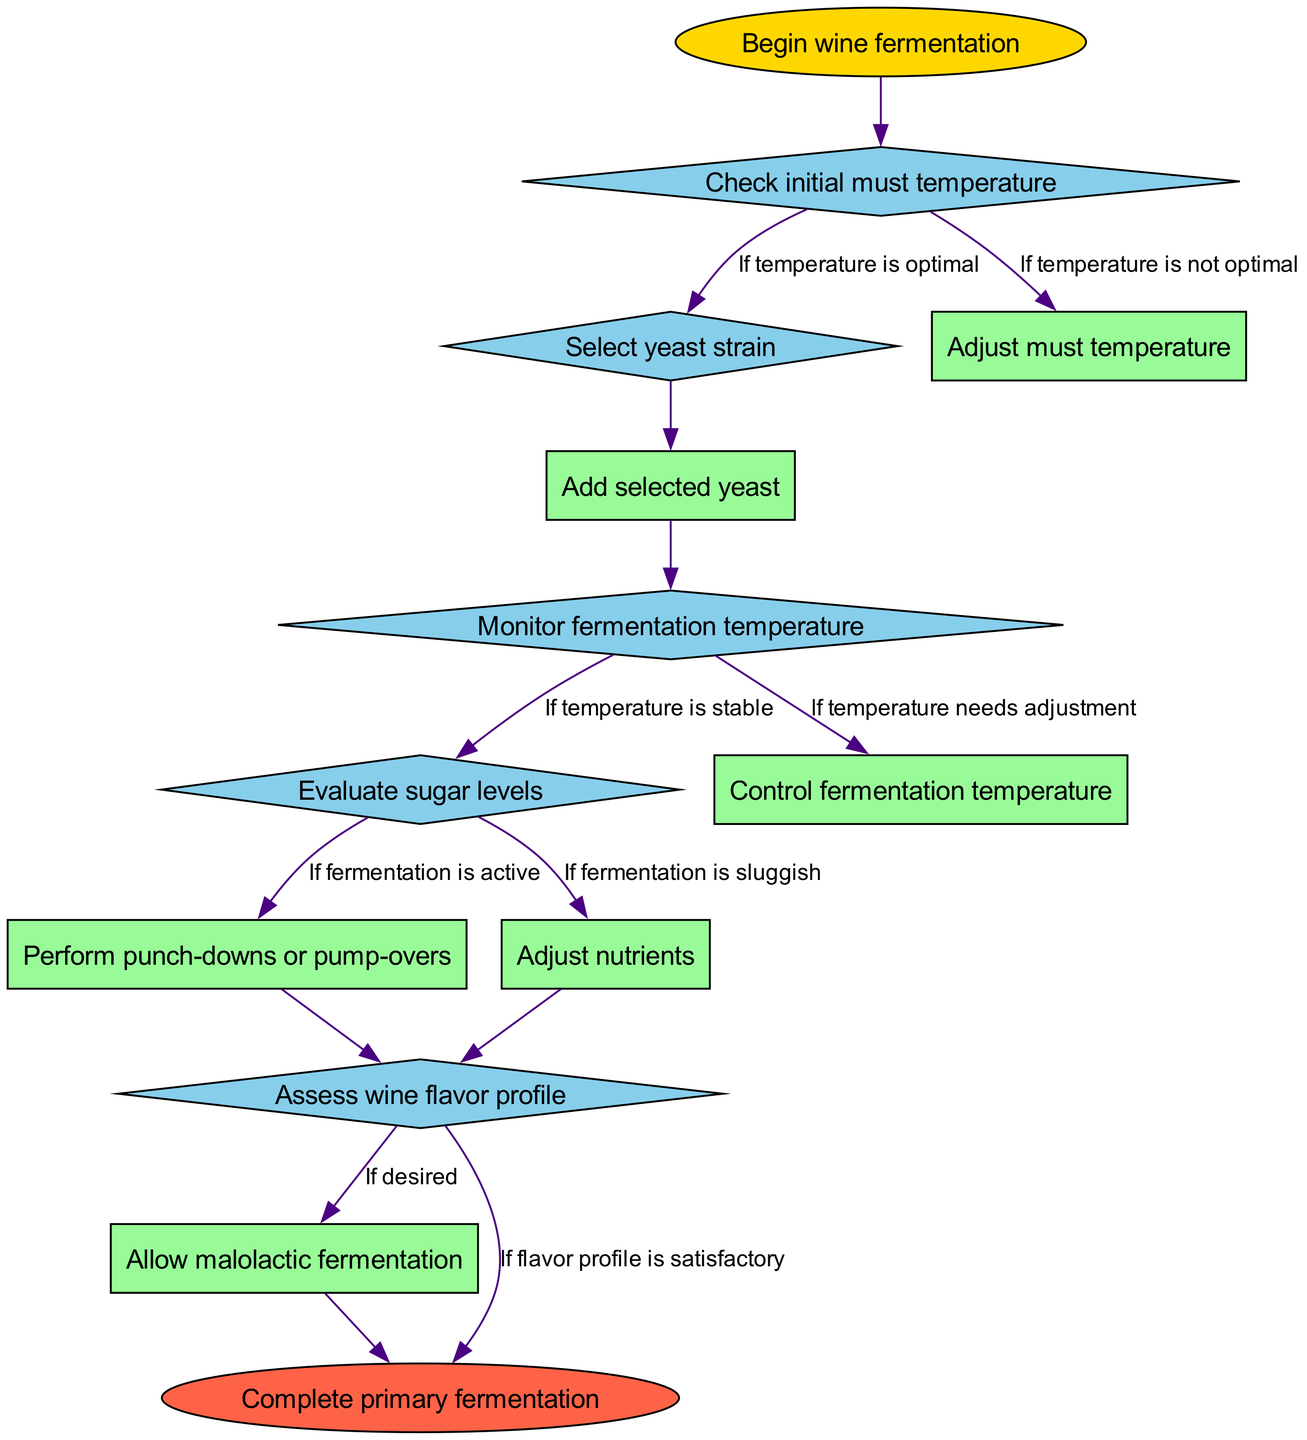What is the initial node of the diagram? The diagram starts at the node labeled "Begin wine fermentation". This node is clearly marked at the top of the flowchart as the first step in the wine fermentation process.
Answer: Begin wine fermentation How many decision nodes are present in the diagram? The diagram lists five decision nodes: "Check initial must temperature", "Select yeast strain", "Monitor fermentation temperature", "Evaluate sugar levels", and "Assess wine flavor profile". Counting these gives a total of five decision nodes.
Answer: 5 What step occurs after the yeast is added? After "Add selected yeast", the next step listed in the flowchart is "Monitor fermentation temperature". This follows immediately after the addition of yeast.
Answer: Monitor fermentation temperature What condition leads to controlling fermentation temperature? The condition that leads to "Control fermentation temperature" is "If temperature needs adjustment". This is directly indicated in the diagram linking those two steps.
Answer: If temperature needs adjustment What happens after assessing the wine flavor profile if it is satisfactory? If the flavor profile is satisfactory, the next step is "Complete primary fermentation". This is indicated in the conditional link from "Assess wine flavor profile" to the end node.
Answer: Complete primary fermentation What options are available if fermentation is sluggish after evaluating sugar levels? If the fermentation is sluggish, the option available is "Adjust nutrients". This is one of the conditions listed under the "Evaluate sugar levels" decision node.
Answer: Adjust nutrients Which process follows the decision to perform punch-downs or pump-overs? The process that follows "Perform punch-downs or pump-overs" is "Assess wine flavor profile", which is the next step in the flow of operations.
Answer: Assess wine flavor profile What is the outcome after allowing malolactic fermentation? After "Allow malolactic fermentation", the final step is "Complete primary fermentation". This leads directly to the end of the process.
Answer: Complete primary fermentation What is the relationship between initial must temperature and yeast strain selection? If the initial must temperature is optimal, the process flows to "Select yeast strain". Conversely, if the temperature is not optimal, the process goes to "Adjust must temperature". This shows the decision-making path based on the temperature check.
Answer: Adjust must temperature or Select yeast strain 